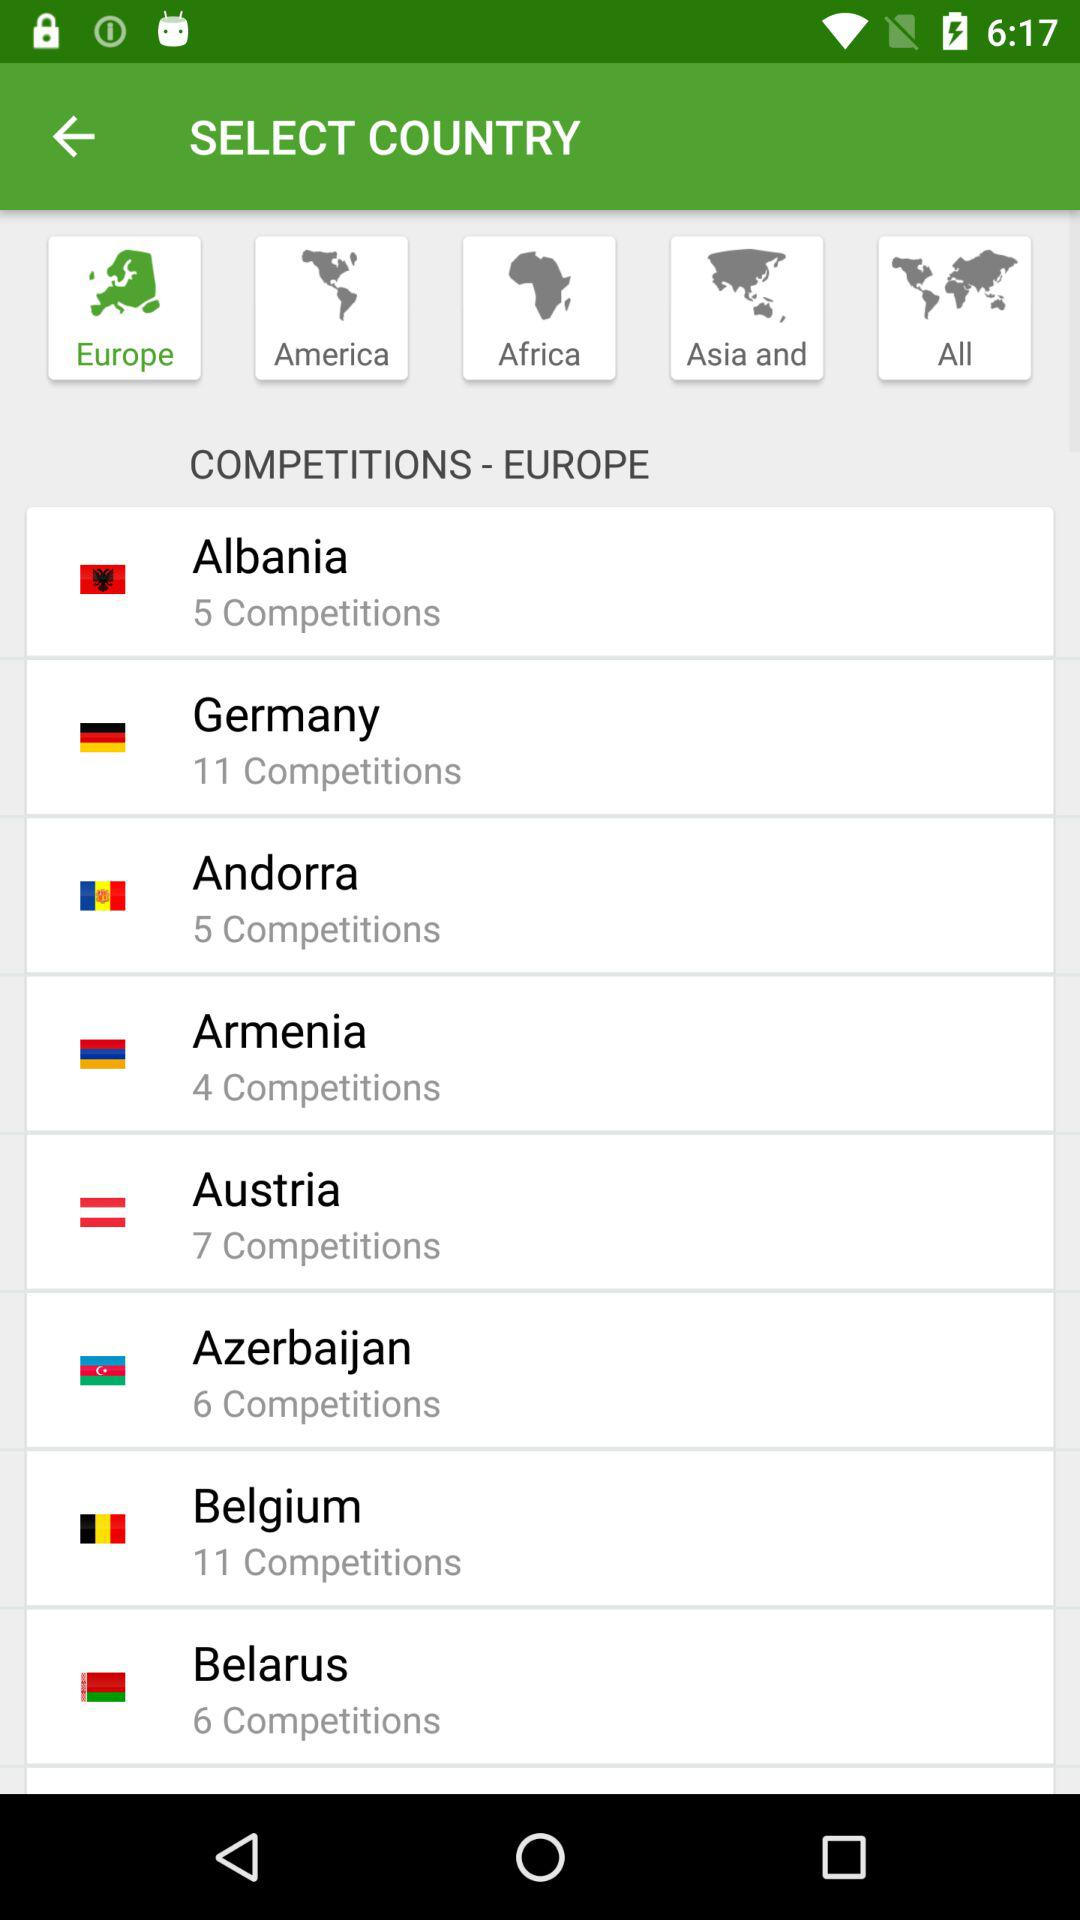Which continent is selected? The selected continent is Europe. 